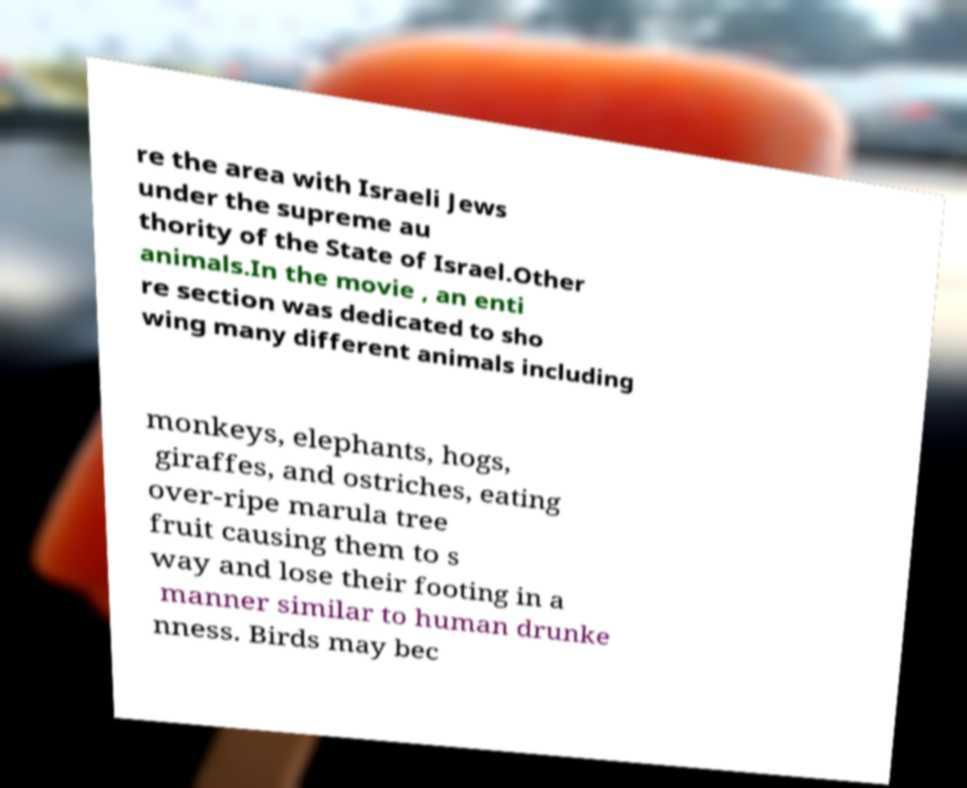For documentation purposes, I need the text within this image transcribed. Could you provide that? re the area with Israeli Jews under the supreme au thority of the State of Israel.Other animals.In the movie , an enti re section was dedicated to sho wing many different animals including monkeys, elephants, hogs, giraffes, and ostriches, eating over-ripe marula tree fruit causing them to s way and lose their footing in a manner similar to human drunke nness. Birds may bec 